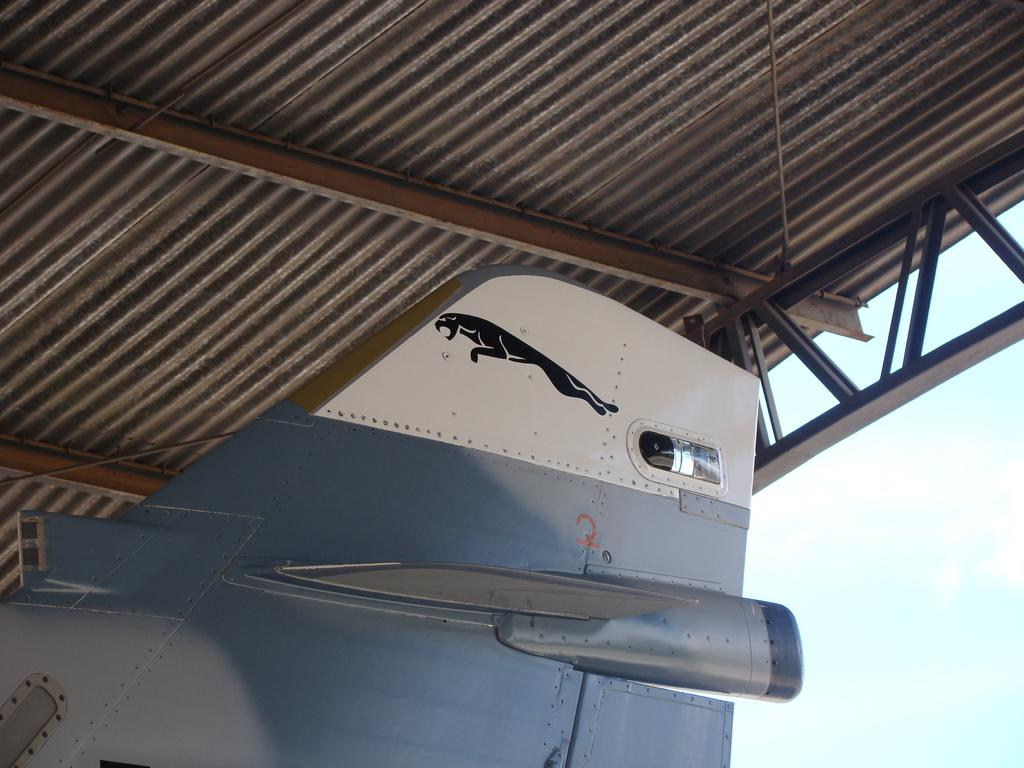What is the color of the aircraft wing in the image? The aircraft wing in the image is grey. What type of structure can be seen in the image? There is an iron frame in the image. What type of building is present in the image? There is a shed in the image. How many deer are visible in the image? There are no deer present in the image. What type of pen is used to write on the shed in the image? There is no pen or writing on the shed in the image. 